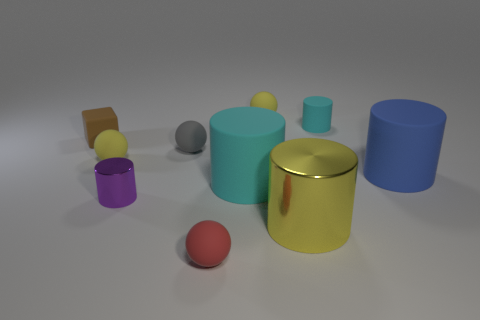Which of these objects has the smoothest surface? The yellow metallic cylinder in the center of the image seems to have the smoothest surface, reflecting the environment with a clear, mirror-like sheen indicating a high level of smoothness. 